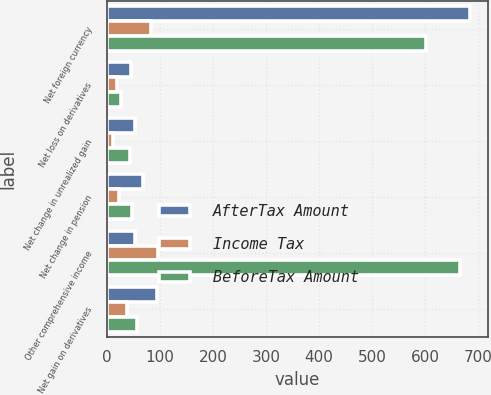<chart> <loc_0><loc_0><loc_500><loc_500><stacked_bar_chart><ecel><fcel>Net foreign currency<fcel>Net loss on derivatives<fcel>Net change in unrealized gain<fcel>Net change in pension<fcel>Other comprehensive income<fcel>Net gain on derivatives<nl><fcel>AfterTax Amount<fcel>685<fcel>44<fcel>53<fcel>68<fcel>53<fcel>94<nl><fcel>Income Tax<fcel>82<fcel>18<fcel>10<fcel>22<fcel>96<fcel>37<nl><fcel>BeforeTax Amount<fcel>603<fcel>26<fcel>43<fcel>46<fcel>666<fcel>57<nl></chart> 